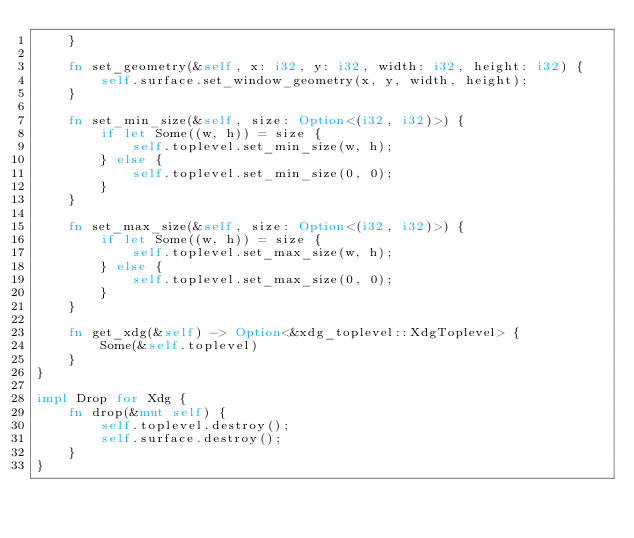Convert code to text. <code><loc_0><loc_0><loc_500><loc_500><_Rust_>    }

    fn set_geometry(&self, x: i32, y: i32, width: i32, height: i32) {
        self.surface.set_window_geometry(x, y, width, height);
    }

    fn set_min_size(&self, size: Option<(i32, i32)>) {
        if let Some((w, h)) = size {
            self.toplevel.set_min_size(w, h);
        } else {
            self.toplevel.set_min_size(0, 0);
        }
    }

    fn set_max_size(&self, size: Option<(i32, i32)>) {
        if let Some((w, h)) = size {
            self.toplevel.set_max_size(w, h);
        } else {
            self.toplevel.set_max_size(0, 0);
        }
    }

    fn get_xdg(&self) -> Option<&xdg_toplevel::XdgToplevel> {
        Some(&self.toplevel)
    }
}

impl Drop for Xdg {
    fn drop(&mut self) {
        self.toplevel.destroy();
        self.surface.destroy();
    }
}
</code> 